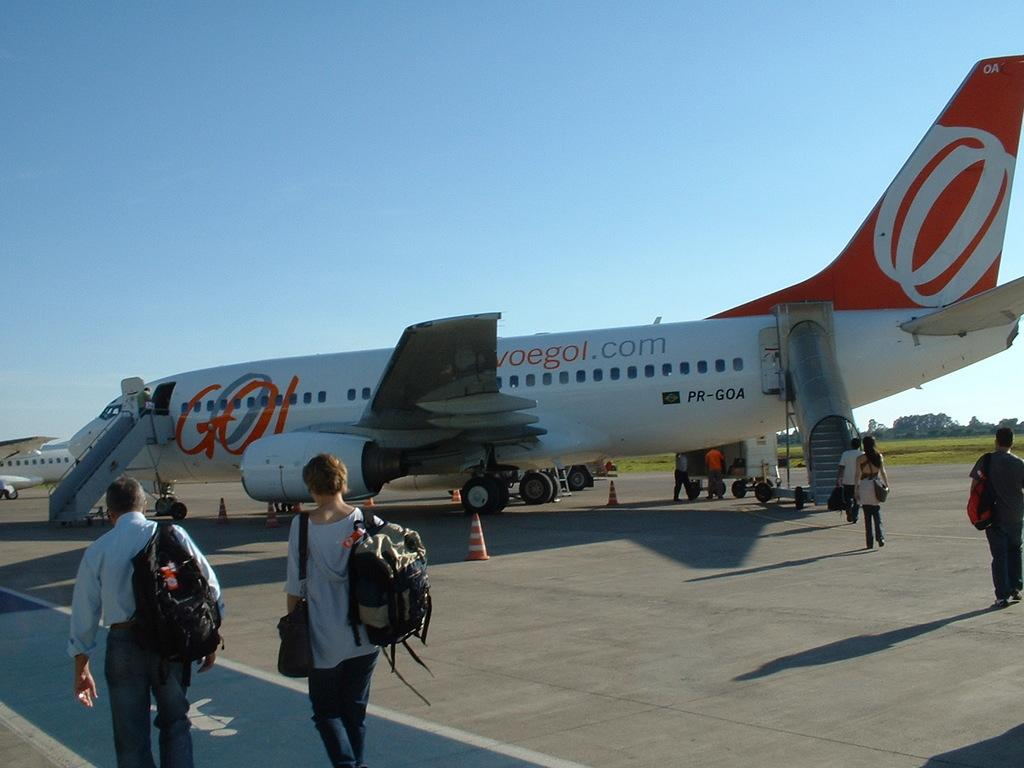<image>
Present a compact description of the photo's key features. A white and red plane that says voegol.com on the side 